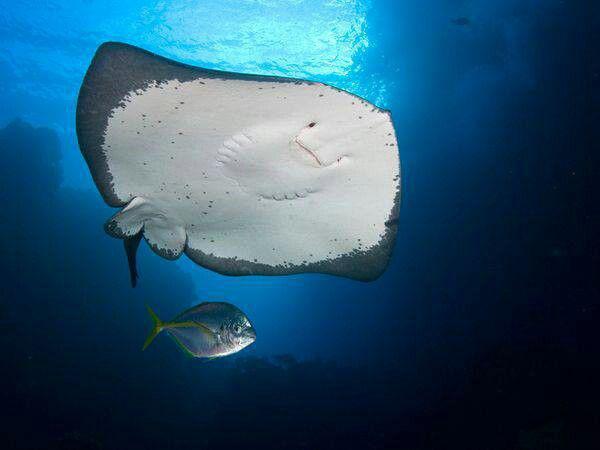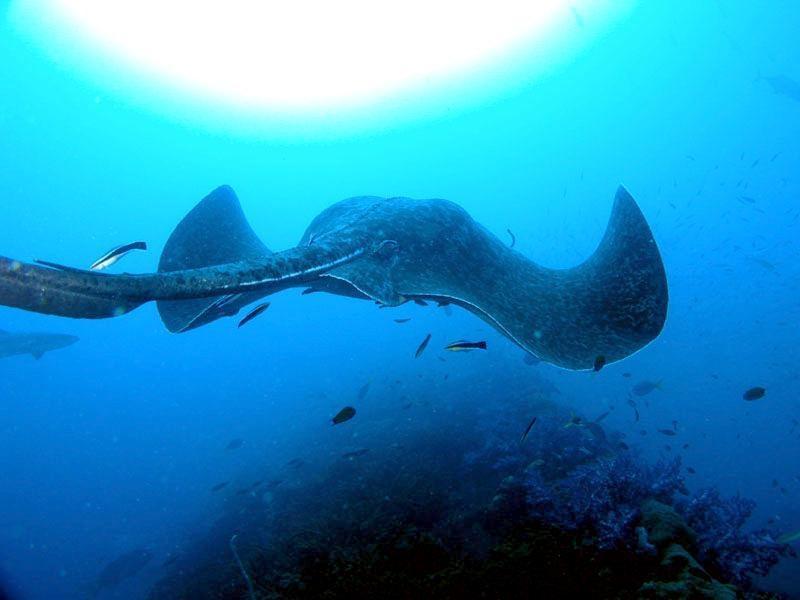The first image is the image on the left, the second image is the image on the right. Given the left and right images, does the statement "The bottom of the manta ray is visible in one of the images." hold true? Answer yes or no. Yes. 